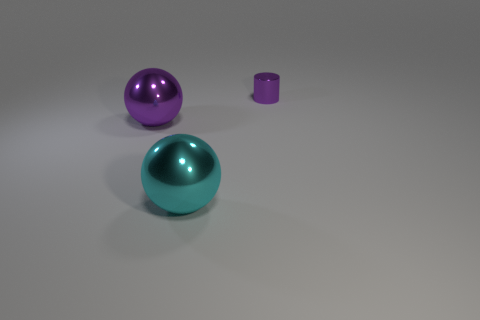What number of objects are either large cyan spheres or big shiny objects behind the cyan ball?
Your answer should be very brief. 2. Are there any other things that are the same shape as the large purple metal thing?
Provide a succinct answer. Yes. Do the purple metal object to the right of the purple sphere and the big cyan shiny ball have the same size?
Offer a very short reply. No. What number of matte objects are either large yellow cubes or purple balls?
Your answer should be compact. 0. How big is the metal sphere that is behind the cyan metal thing?
Give a very brief answer. Large. Do the big cyan thing and the large purple metal thing have the same shape?
Your answer should be compact. Yes. How many large things are brown metal balls or cylinders?
Your answer should be very brief. 0. There is a cyan metal ball; are there any shiny things on the left side of it?
Offer a terse response. Yes. Are there an equal number of spheres behind the cylinder and big shiny cylinders?
Keep it short and to the point. Yes. The purple metallic object that is the same shape as the cyan shiny thing is what size?
Offer a terse response. Large. 